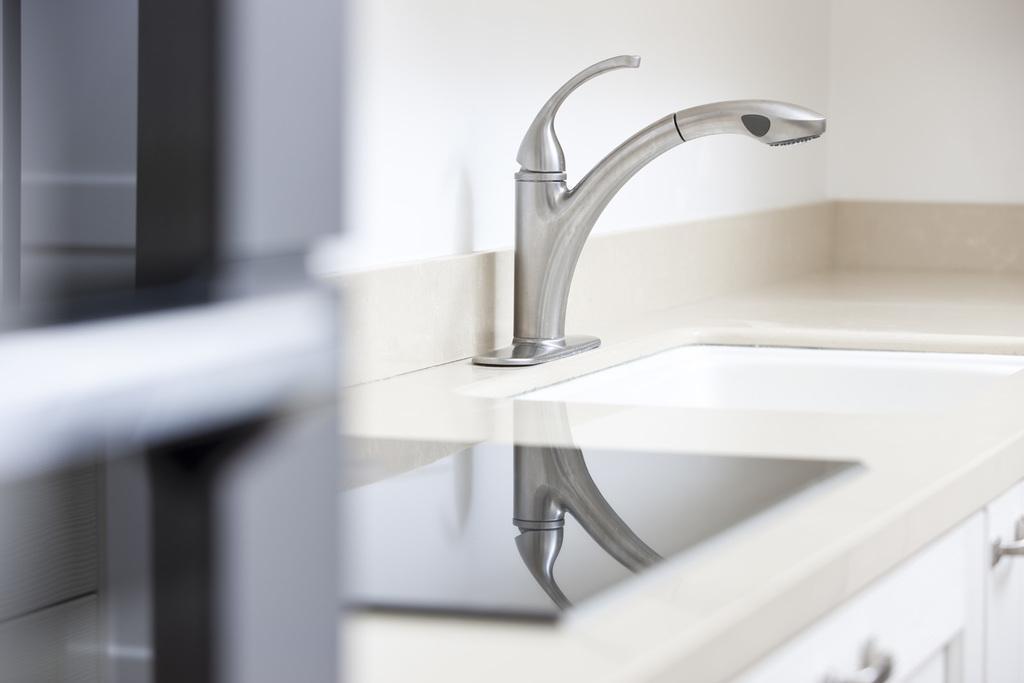Can you describe this image briefly? In this image we can see sink, tap, cupboard, countertop and white color wall. 